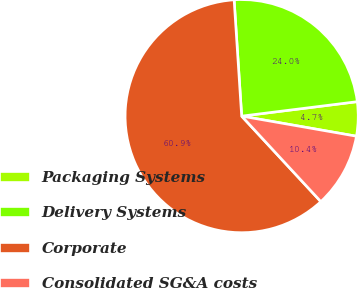Convert chart to OTSL. <chart><loc_0><loc_0><loc_500><loc_500><pie_chart><fcel>Packaging Systems<fcel>Delivery Systems<fcel>Corporate<fcel>Consolidated SG&A costs<nl><fcel>4.74%<fcel>24.05%<fcel>60.86%<fcel>10.35%<nl></chart> 